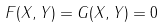<formula> <loc_0><loc_0><loc_500><loc_500>F ( X , Y ) = G ( X , Y ) = 0</formula> 